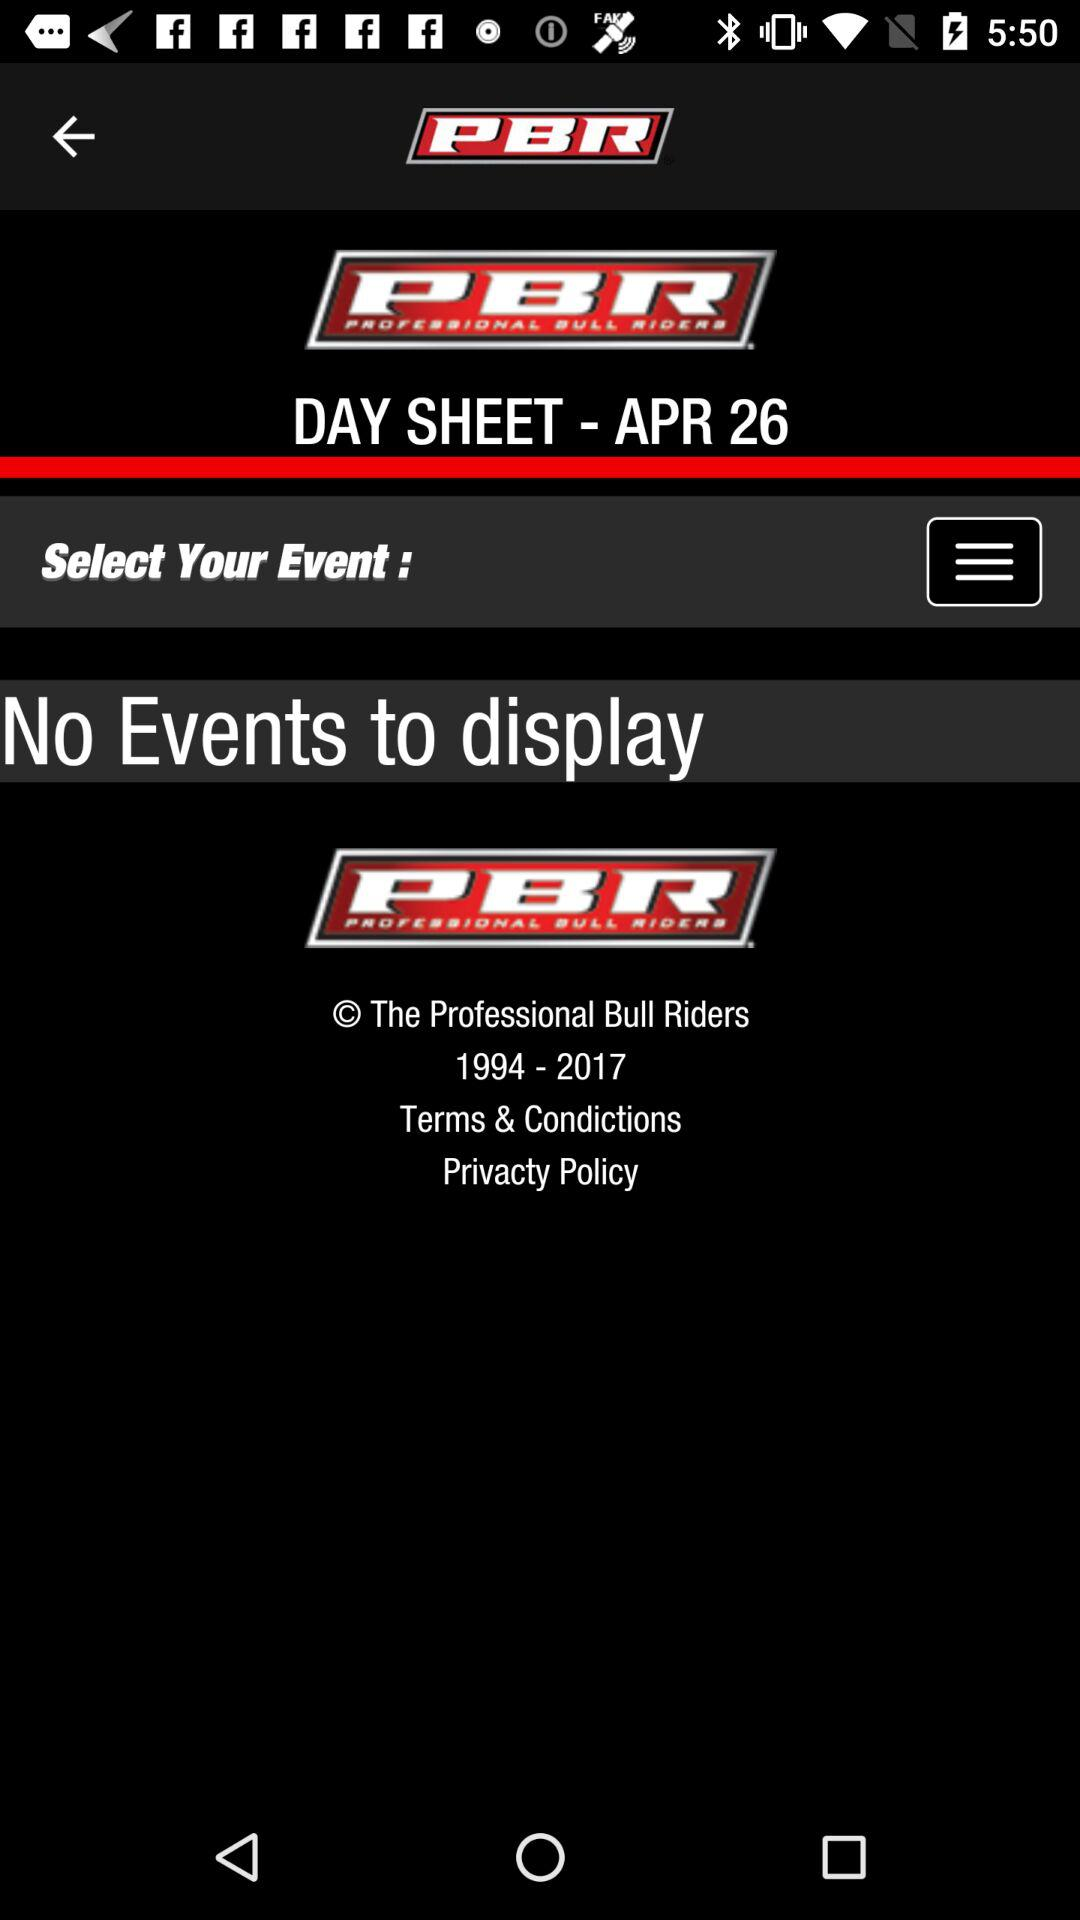What is the full form of PBR? The full form of PBR is Professional Bull Riders. 